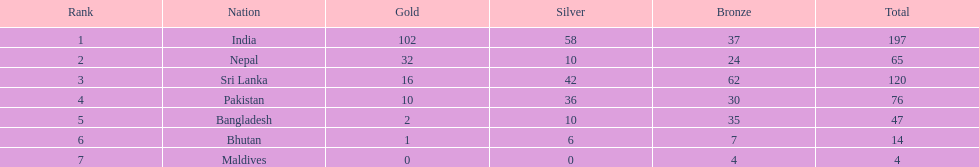What was the quantity of silver medals secured by pakistan? 36. 